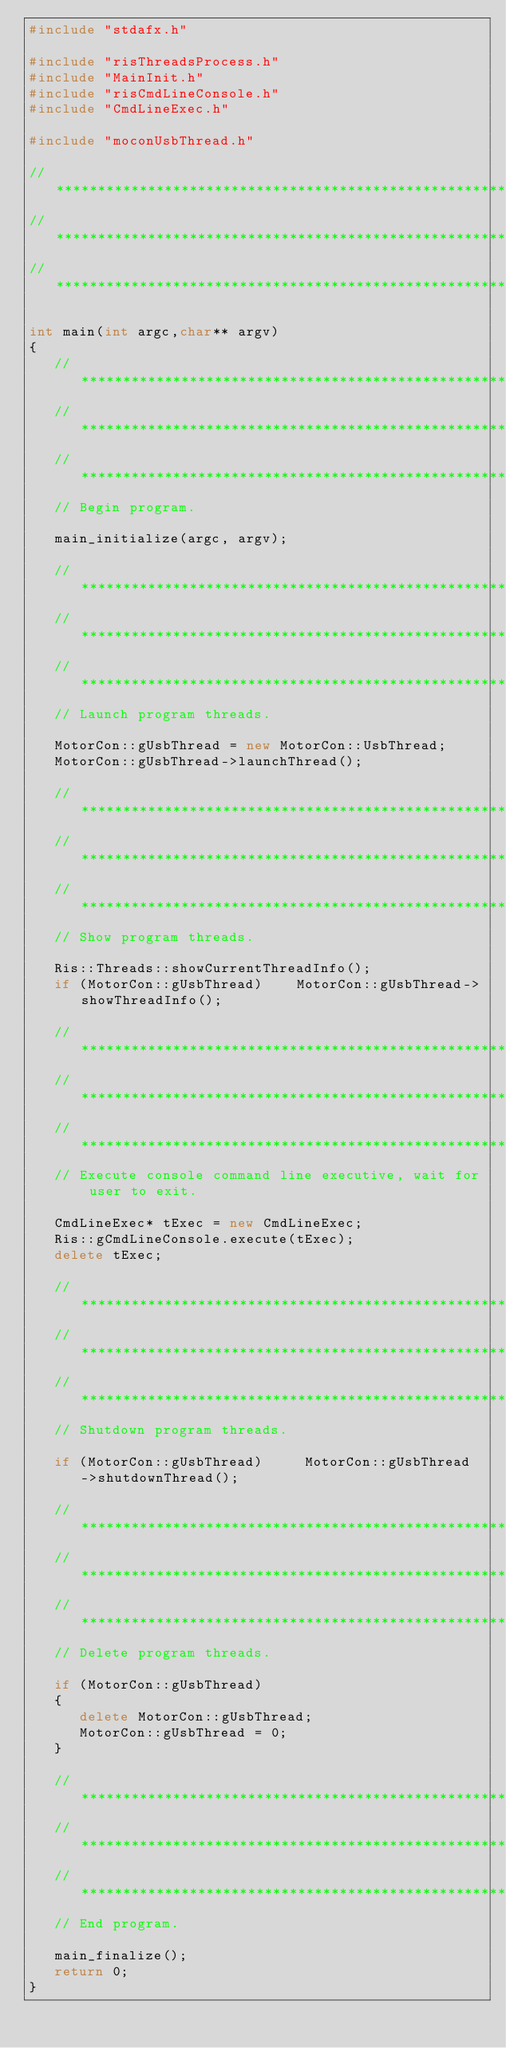Convert code to text. <code><loc_0><loc_0><loc_500><loc_500><_C++_>#include "stdafx.h"

#include "risThreadsProcess.h"
#include "MainInit.h"
#include "risCmdLineConsole.h"
#include "CmdLineExec.h"

#include "moconUsbThread.h"

//******************************************************************************
//******************************************************************************
//******************************************************************************

int main(int argc,char** argv)
{
   //***************************************************************************
   //***************************************************************************
   //***************************************************************************
   // Begin program.

   main_initialize(argc, argv);

   //***************************************************************************
   //***************************************************************************
   //***************************************************************************
   // Launch program threads.

   MotorCon::gUsbThread = new MotorCon::UsbThread;
   MotorCon::gUsbThread->launchThread();

   //***************************************************************************
   //***************************************************************************
   //***************************************************************************
   // Show program threads.

   Ris::Threads::showCurrentThreadInfo();
   if (MotorCon::gUsbThread)    MotorCon::gUsbThread->showThreadInfo();

   //***************************************************************************
   //***************************************************************************
   //***************************************************************************
   // Execute console command line executive, wait for user to exit.

   CmdLineExec* tExec = new CmdLineExec;
   Ris::gCmdLineConsole.execute(tExec);
   delete tExec;

   //***************************************************************************
   //***************************************************************************
   //***************************************************************************
   // Shutdown program threads.

   if (MotorCon::gUsbThread)     MotorCon::gUsbThread->shutdownThread();

   //***************************************************************************
   //***************************************************************************
   //***************************************************************************
   // Delete program threads.

   if (MotorCon::gUsbThread)
   {
      delete MotorCon::gUsbThread;
      MotorCon::gUsbThread = 0;
   }

   //***************************************************************************
   //***************************************************************************
   //***************************************************************************
   // End program.

   main_finalize();
   return 0;
}
</code> 